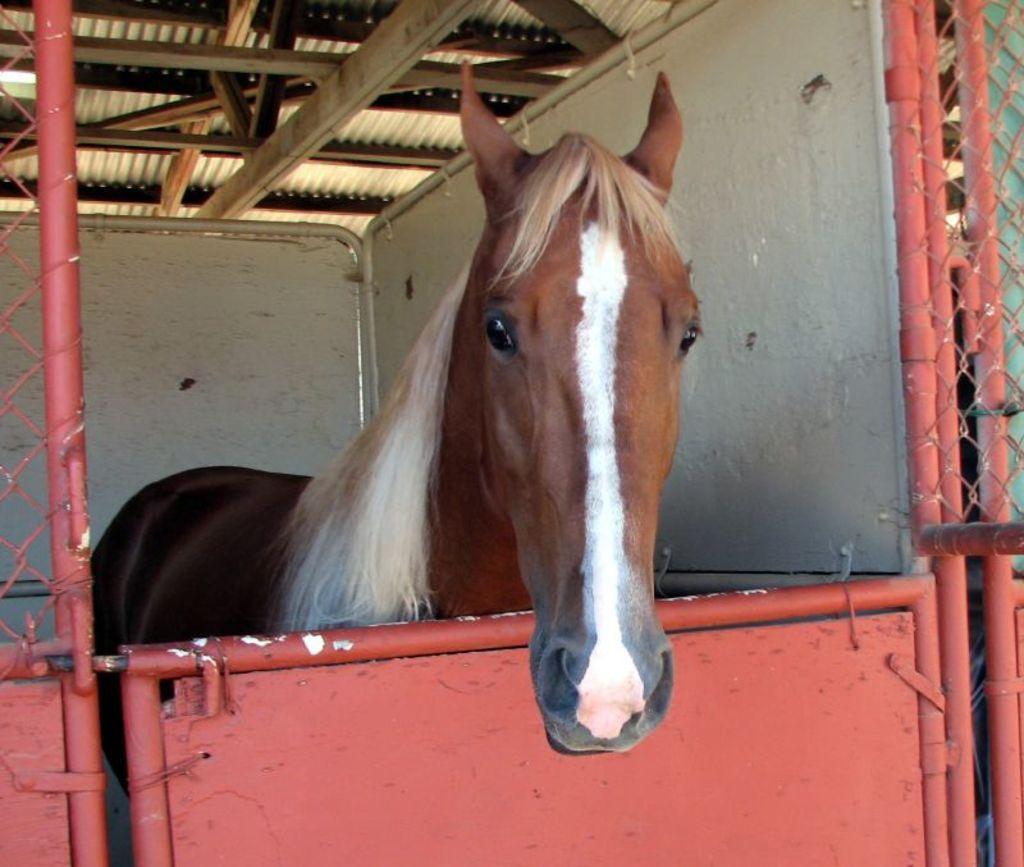Please provide a concise description of this image. In this image there is a horse in a cage, at the top there is a roof. 